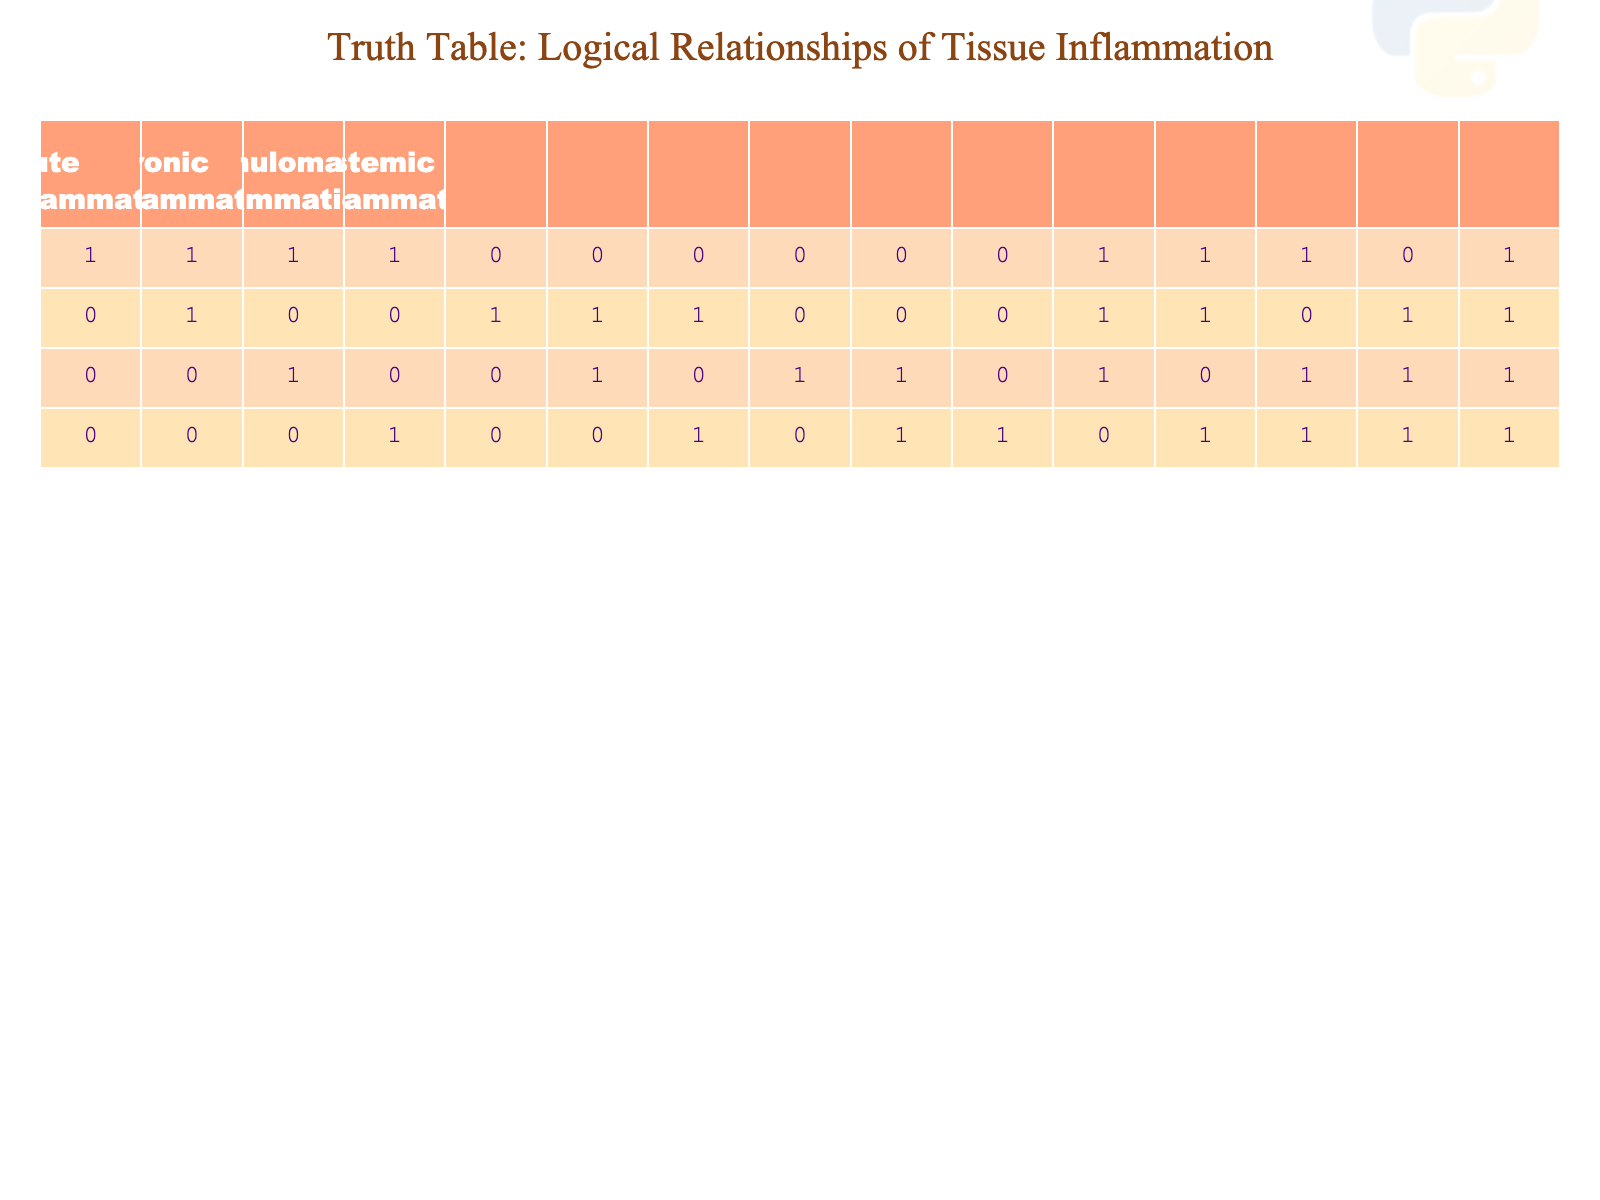What is the total number of rows representing Acute Inflammation? To find the total for Acute Inflammation, we count how many rows have a value of '1' in that column. There are 8 rows where Acute Inflammation is indicated (the first, second, third, fourth, eleventh, twelfth, thirteenth, and fifteenth rows).
Answer: 8 How many types of inflammation are present in the combination of Acute and Chronic Inflammation? We look for rows where there is a value of '1' in both the Acute and Chronic columns. Upon counting, we find that there are 4 such combinations (rows two, five, eleven, and fourteenth).
Answer: 4 Is there any row where all types of inflammation are present? We examine each row to see if all columns (Acute, Chronic, Granulomatous, Systemic) have a value of '1'. The only row that satisfies this is the fifteenth row, indicating that it represents all types of inflammation.
Answer: Yes What is the number of rows indicating Granulomatous Inflammation without any of the other types? We need to find the row(s) where Granulomatous Inflammation has a value of '1' and both Acute and Chronic Inflammation are '0'. Only the eighth row satisfies this condition.
Answer: 1 In how many scenarios is Chronic Inflammation present without Systemic Inflammation? To find this, we need to filter the rows for Chronic Inflammation ('1') while ensuring that Systemic Inflammation is '0'. Counting those rows, we find that there are 5 (rows five, six, seven, and eight).
Answer: 5 Which type of inflammation is solely represented in the fifth row? In the fifth row, Acute Inflammation is '0', Chronic Inflammation is '1', Granulomatous is '0', and Systemic is '0'. This means that only Chronic Inflammation is present in that row.
Answer: Chronic Inflammation If we consider rows where both Chronic and Systemic Inflammation are present, how many of them also indicate Acute Inflammation? We first find rows where both Chronic and Systemic have a value of '1'; there are three such rows: the tenth, thirteenth, and fifteenth. Out of these, only the fifteenth row also indicates Acute Inflammation is '1'.
Answer: 1 What percentage of the total rows indicate Systemic Inflammation? There are a total of 15 rows. We count how many rows show '1' for Systemic Inflammation; there are 6 such rows (rows four, ten, eleventh, twelfth, thirteenth, and fifteenth). The percentage is calculated as (6/15) * 100 = 40%.
Answer: 40% 